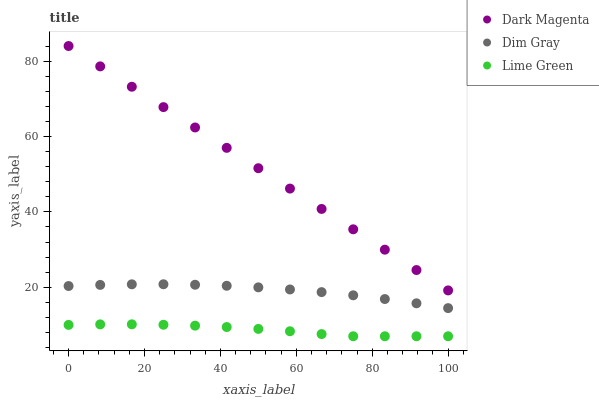Does Lime Green have the minimum area under the curve?
Answer yes or no. Yes. Does Dark Magenta have the maximum area under the curve?
Answer yes or no. Yes. Does Dark Magenta have the minimum area under the curve?
Answer yes or no. No. Does Lime Green have the maximum area under the curve?
Answer yes or no. No. Is Dark Magenta the smoothest?
Answer yes or no. Yes. Is Lime Green the roughest?
Answer yes or no. Yes. Is Lime Green the smoothest?
Answer yes or no. No. Is Dark Magenta the roughest?
Answer yes or no. No. Does Lime Green have the lowest value?
Answer yes or no. Yes. Does Dark Magenta have the lowest value?
Answer yes or no. No. Does Dark Magenta have the highest value?
Answer yes or no. Yes. Does Lime Green have the highest value?
Answer yes or no. No. Is Lime Green less than Dark Magenta?
Answer yes or no. Yes. Is Dark Magenta greater than Dim Gray?
Answer yes or no. Yes. Does Lime Green intersect Dark Magenta?
Answer yes or no. No. 